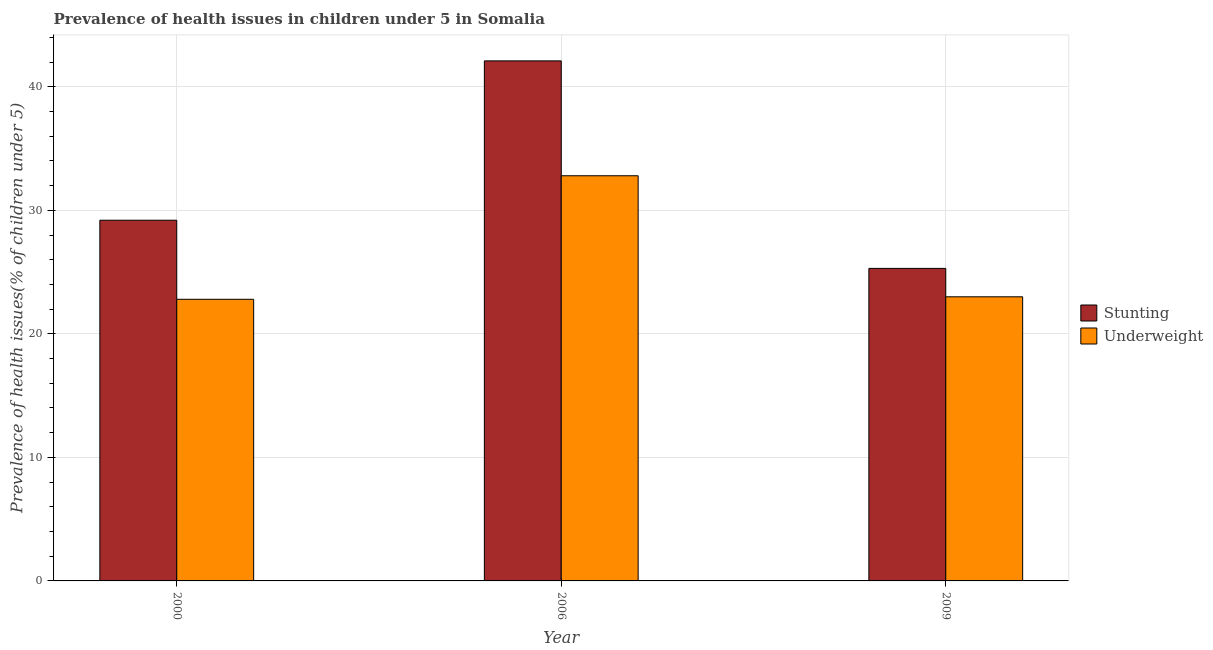Are the number of bars on each tick of the X-axis equal?
Your answer should be very brief. Yes. How many bars are there on the 2nd tick from the left?
Your answer should be compact. 2. What is the percentage of underweight children in 2006?
Provide a succinct answer. 32.8. Across all years, what is the maximum percentage of stunted children?
Ensure brevity in your answer.  42.1. Across all years, what is the minimum percentage of stunted children?
Your response must be concise. 25.3. In which year was the percentage of stunted children maximum?
Provide a succinct answer. 2006. What is the total percentage of stunted children in the graph?
Keep it short and to the point. 96.6. What is the difference between the percentage of stunted children in 2000 and that in 2006?
Keep it short and to the point. -12.9. What is the difference between the percentage of underweight children in 2009 and the percentage of stunted children in 2000?
Keep it short and to the point. 0.2. What is the average percentage of stunted children per year?
Make the answer very short. 32.2. In the year 2009, what is the difference between the percentage of underweight children and percentage of stunted children?
Keep it short and to the point. 0. In how many years, is the percentage of underweight children greater than 30 %?
Offer a very short reply. 1. What is the ratio of the percentage of stunted children in 2006 to that in 2009?
Your response must be concise. 1.66. What is the difference between the highest and the second highest percentage of underweight children?
Provide a short and direct response. 9.8. What is the difference between the highest and the lowest percentage of underweight children?
Your answer should be very brief. 10. In how many years, is the percentage of underweight children greater than the average percentage of underweight children taken over all years?
Your answer should be very brief. 1. Is the sum of the percentage of underweight children in 2000 and 2009 greater than the maximum percentage of stunted children across all years?
Keep it short and to the point. Yes. What does the 2nd bar from the left in 2009 represents?
Offer a very short reply. Underweight. What does the 1st bar from the right in 2000 represents?
Keep it short and to the point. Underweight. Are all the bars in the graph horizontal?
Provide a short and direct response. No. How many legend labels are there?
Give a very brief answer. 2. What is the title of the graph?
Provide a short and direct response. Prevalence of health issues in children under 5 in Somalia. What is the label or title of the X-axis?
Your answer should be very brief. Year. What is the label or title of the Y-axis?
Provide a short and direct response. Prevalence of health issues(% of children under 5). What is the Prevalence of health issues(% of children under 5) in Stunting in 2000?
Provide a short and direct response. 29.2. What is the Prevalence of health issues(% of children under 5) of Underweight in 2000?
Your answer should be very brief. 22.8. What is the Prevalence of health issues(% of children under 5) in Stunting in 2006?
Ensure brevity in your answer.  42.1. What is the Prevalence of health issues(% of children under 5) in Underweight in 2006?
Your answer should be very brief. 32.8. What is the Prevalence of health issues(% of children under 5) in Stunting in 2009?
Your answer should be compact. 25.3. Across all years, what is the maximum Prevalence of health issues(% of children under 5) of Stunting?
Ensure brevity in your answer.  42.1. Across all years, what is the maximum Prevalence of health issues(% of children under 5) of Underweight?
Ensure brevity in your answer.  32.8. Across all years, what is the minimum Prevalence of health issues(% of children under 5) in Stunting?
Keep it short and to the point. 25.3. Across all years, what is the minimum Prevalence of health issues(% of children under 5) of Underweight?
Keep it short and to the point. 22.8. What is the total Prevalence of health issues(% of children under 5) in Stunting in the graph?
Ensure brevity in your answer.  96.6. What is the total Prevalence of health issues(% of children under 5) of Underweight in the graph?
Provide a short and direct response. 78.6. What is the difference between the Prevalence of health issues(% of children under 5) in Stunting in 2000 and that in 2006?
Keep it short and to the point. -12.9. What is the difference between the Prevalence of health issues(% of children under 5) of Stunting in 2000 and that in 2009?
Keep it short and to the point. 3.9. What is the difference between the Prevalence of health issues(% of children under 5) in Underweight in 2000 and that in 2009?
Offer a terse response. -0.2. What is the difference between the Prevalence of health issues(% of children under 5) of Stunting in 2006 and that in 2009?
Your answer should be very brief. 16.8. What is the difference between the Prevalence of health issues(% of children under 5) of Underweight in 2006 and that in 2009?
Make the answer very short. 9.8. What is the difference between the Prevalence of health issues(% of children under 5) of Stunting in 2000 and the Prevalence of health issues(% of children under 5) of Underweight in 2006?
Your answer should be very brief. -3.6. What is the difference between the Prevalence of health issues(% of children under 5) of Stunting in 2000 and the Prevalence of health issues(% of children under 5) of Underweight in 2009?
Provide a succinct answer. 6.2. What is the difference between the Prevalence of health issues(% of children under 5) in Stunting in 2006 and the Prevalence of health issues(% of children under 5) in Underweight in 2009?
Keep it short and to the point. 19.1. What is the average Prevalence of health issues(% of children under 5) in Stunting per year?
Offer a very short reply. 32.2. What is the average Prevalence of health issues(% of children under 5) of Underweight per year?
Give a very brief answer. 26.2. What is the ratio of the Prevalence of health issues(% of children under 5) in Stunting in 2000 to that in 2006?
Keep it short and to the point. 0.69. What is the ratio of the Prevalence of health issues(% of children under 5) of Underweight in 2000 to that in 2006?
Your response must be concise. 0.7. What is the ratio of the Prevalence of health issues(% of children under 5) of Stunting in 2000 to that in 2009?
Your response must be concise. 1.15. What is the ratio of the Prevalence of health issues(% of children under 5) in Stunting in 2006 to that in 2009?
Keep it short and to the point. 1.66. What is the ratio of the Prevalence of health issues(% of children under 5) in Underweight in 2006 to that in 2009?
Offer a very short reply. 1.43. What is the difference between the highest and the lowest Prevalence of health issues(% of children under 5) in Stunting?
Keep it short and to the point. 16.8. 